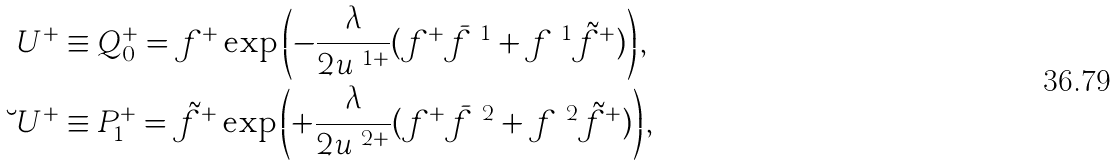<formula> <loc_0><loc_0><loc_500><loc_500>\ U ^ { + } & \equiv Q _ { 0 } ^ { + } = f ^ { + } \exp \left ( - \frac { \lambda } { 2 u ^ { \ 1 + } } ( f ^ { + } \bar { f } ^ { \ 1 } + f ^ { \ 1 } \tilde { f } ^ { + } ) \right ) , \\ \breve { \ } U ^ { + } & \equiv P _ { 1 } ^ { + } = \tilde { f } ^ { + } \exp \left ( + \frac { \lambda } { 2 u ^ { \ 2 + } } ( f ^ { + } \bar { f } ^ { \ 2 } + f ^ { \ 2 } \tilde { f } ^ { + } ) \right ) ,</formula> 